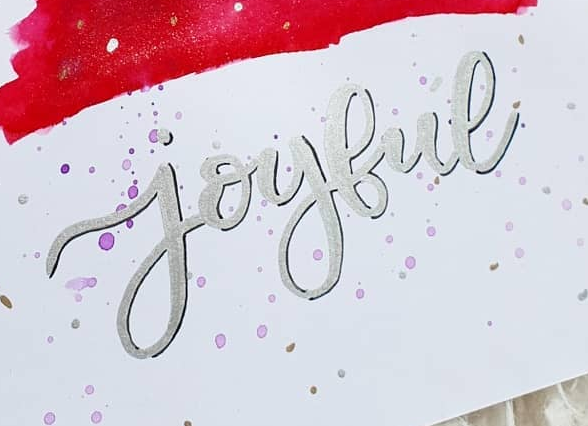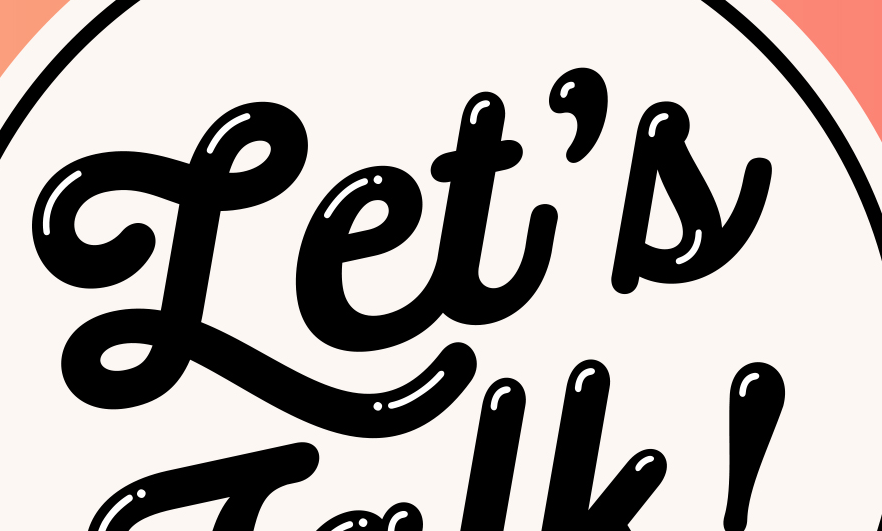Read the text from these images in sequence, separated by a semicolon. joybue; Let's 